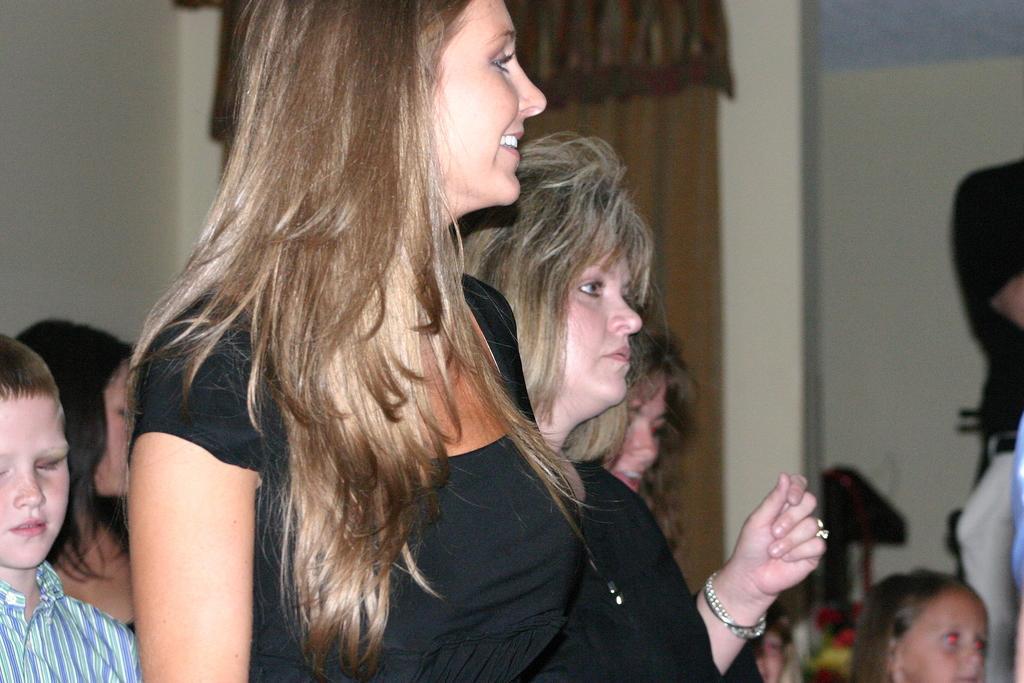In one or two sentences, can you explain what this image depicts? In this picture we can observe a woman standing, wearing black color dress. She is smiling. In the background there are some people. We can observe children and women. There is a wall and a brown color curtain in the background. 